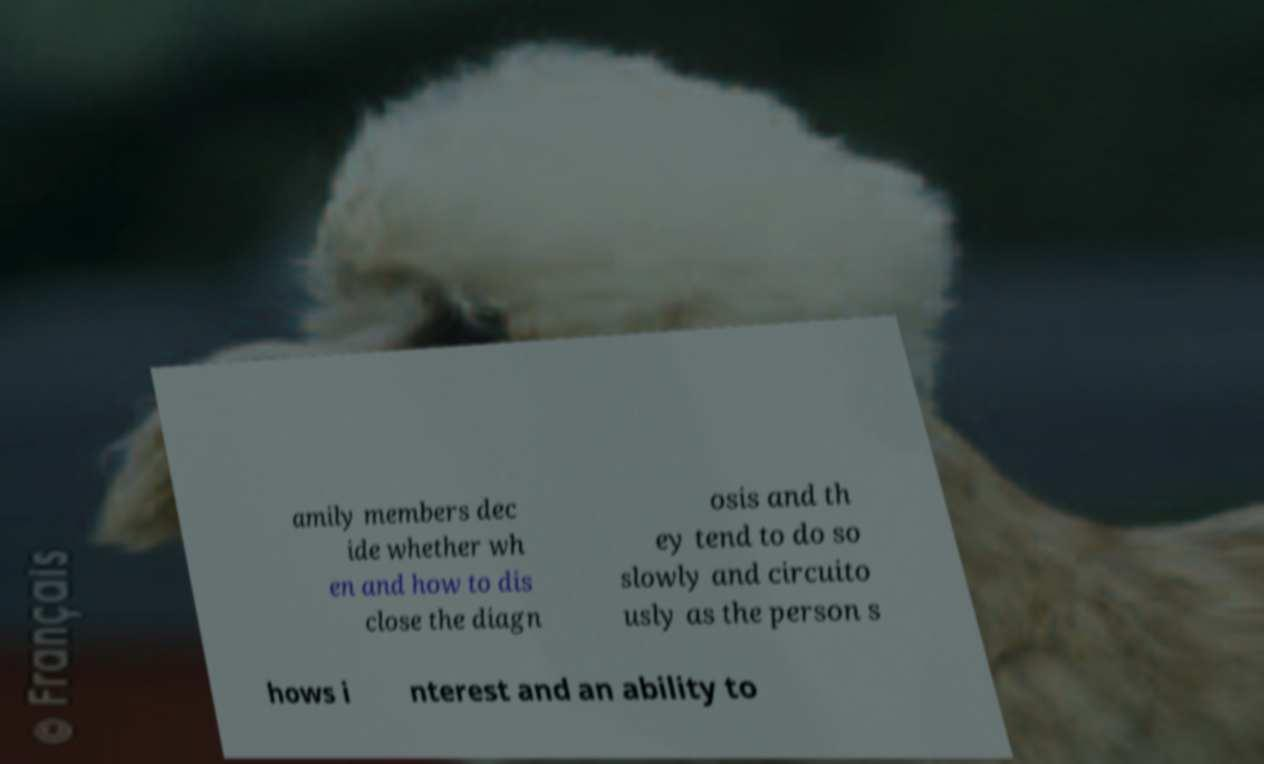Could you assist in decoding the text presented in this image and type it out clearly? amily members dec ide whether wh en and how to dis close the diagn osis and th ey tend to do so slowly and circuito usly as the person s hows i nterest and an ability to 